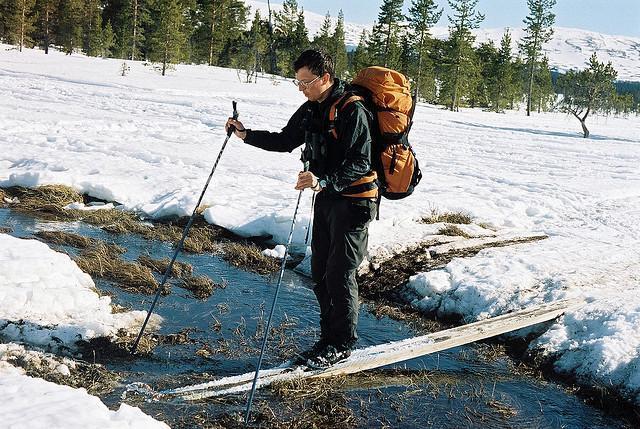How many blue trains can you see?
Give a very brief answer. 0. 